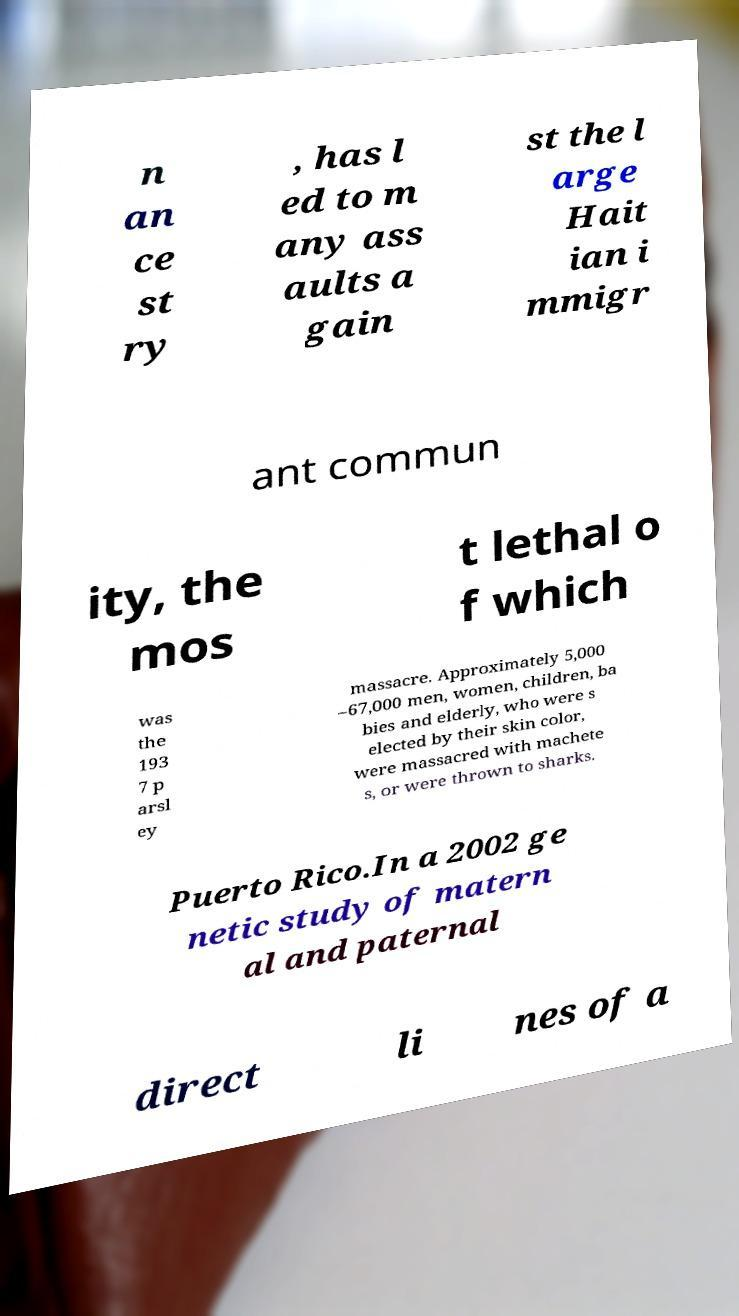Could you extract and type out the text from this image? n an ce st ry , has l ed to m any ass aults a gain st the l arge Hait ian i mmigr ant commun ity, the mos t lethal o f which was the 193 7 p arsl ey massacre. Approximately 5,000 –67,000 men, women, children, ba bies and elderly, who were s elected by their skin color, were massacred with machete s, or were thrown to sharks. Puerto Rico.In a 2002 ge netic study of matern al and paternal direct li nes of a 